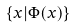<formula> <loc_0><loc_0><loc_500><loc_500>\{ x | \Phi ( x ) \}</formula> 